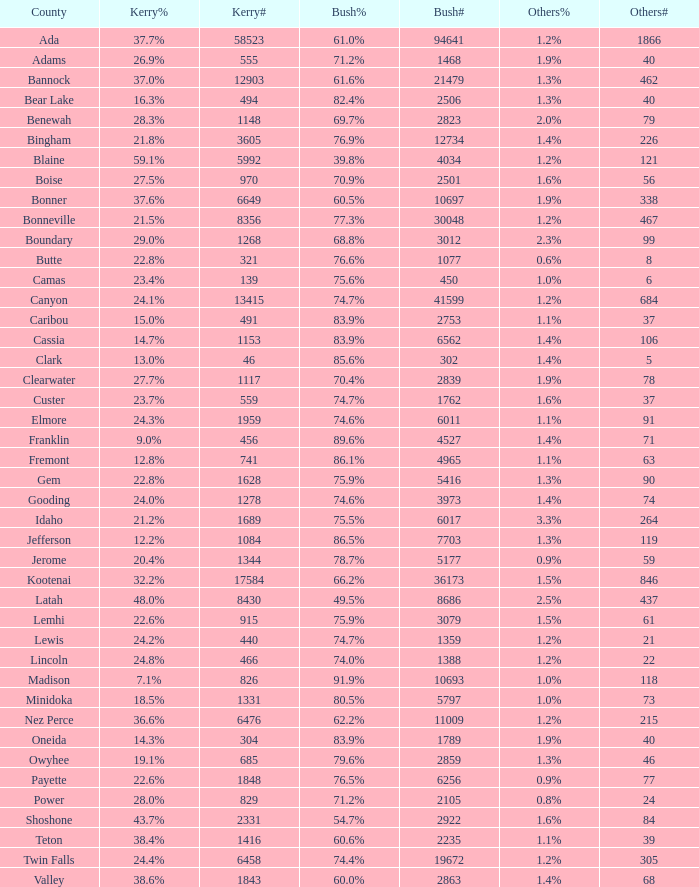What proportion of bonneville's population cast their vote for bush? 77.3%. Write the full table. {'header': ['County', 'Kerry%', 'Kerry#', 'Bush%', 'Bush#', 'Others%', 'Others#'], 'rows': [['Ada', '37.7%', '58523', '61.0%', '94641', '1.2%', '1866'], ['Adams', '26.9%', '555', '71.2%', '1468', '1.9%', '40'], ['Bannock', '37.0%', '12903', '61.6%', '21479', '1.3%', '462'], ['Bear Lake', '16.3%', '494', '82.4%', '2506', '1.3%', '40'], ['Benewah', '28.3%', '1148', '69.7%', '2823', '2.0%', '79'], ['Bingham', '21.8%', '3605', '76.9%', '12734', '1.4%', '226'], ['Blaine', '59.1%', '5992', '39.8%', '4034', '1.2%', '121'], ['Boise', '27.5%', '970', '70.9%', '2501', '1.6%', '56'], ['Bonner', '37.6%', '6649', '60.5%', '10697', '1.9%', '338'], ['Bonneville', '21.5%', '8356', '77.3%', '30048', '1.2%', '467'], ['Boundary', '29.0%', '1268', '68.8%', '3012', '2.3%', '99'], ['Butte', '22.8%', '321', '76.6%', '1077', '0.6%', '8'], ['Camas', '23.4%', '139', '75.6%', '450', '1.0%', '6'], ['Canyon', '24.1%', '13415', '74.7%', '41599', '1.2%', '684'], ['Caribou', '15.0%', '491', '83.9%', '2753', '1.1%', '37'], ['Cassia', '14.7%', '1153', '83.9%', '6562', '1.4%', '106'], ['Clark', '13.0%', '46', '85.6%', '302', '1.4%', '5'], ['Clearwater', '27.7%', '1117', '70.4%', '2839', '1.9%', '78'], ['Custer', '23.7%', '559', '74.7%', '1762', '1.6%', '37'], ['Elmore', '24.3%', '1959', '74.6%', '6011', '1.1%', '91'], ['Franklin', '9.0%', '456', '89.6%', '4527', '1.4%', '71'], ['Fremont', '12.8%', '741', '86.1%', '4965', '1.1%', '63'], ['Gem', '22.8%', '1628', '75.9%', '5416', '1.3%', '90'], ['Gooding', '24.0%', '1278', '74.6%', '3973', '1.4%', '74'], ['Idaho', '21.2%', '1689', '75.5%', '6017', '3.3%', '264'], ['Jefferson', '12.2%', '1084', '86.5%', '7703', '1.3%', '119'], ['Jerome', '20.4%', '1344', '78.7%', '5177', '0.9%', '59'], ['Kootenai', '32.2%', '17584', '66.2%', '36173', '1.5%', '846'], ['Latah', '48.0%', '8430', '49.5%', '8686', '2.5%', '437'], ['Lemhi', '22.6%', '915', '75.9%', '3079', '1.5%', '61'], ['Lewis', '24.2%', '440', '74.7%', '1359', '1.2%', '21'], ['Lincoln', '24.8%', '466', '74.0%', '1388', '1.2%', '22'], ['Madison', '7.1%', '826', '91.9%', '10693', '1.0%', '118'], ['Minidoka', '18.5%', '1331', '80.5%', '5797', '1.0%', '73'], ['Nez Perce', '36.6%', '6476', '62.2%', '11009', '1.2%', '215'], ['Oneida', '14.3%', '304', '83.9%', '1789', '1.9%', '40'], ['Owyhee', '19.1%', '685', '79.6%', '2859', '1.3%', '46'], ['Payette', '22.6%', '1848', '76.5%', '6256', '0.9%', '77'], ['Power', '28.0%', '829', '71.2%', '2105', '0.8%', '24'], ['Shoshone', '43.7%', '2331', '54.7%', '2922', '1.6%', '84'], ['Teton', '38.4%', '1416', '60.6%', '2235', '1.1%', '39'], ['Twin Falls', '24.4%', '6458', '74.4%', '19672', '1.2%', '305'], ['Valley', '38.6%', '1843', '60.0%', '2863', '1.4%', '68']]} 